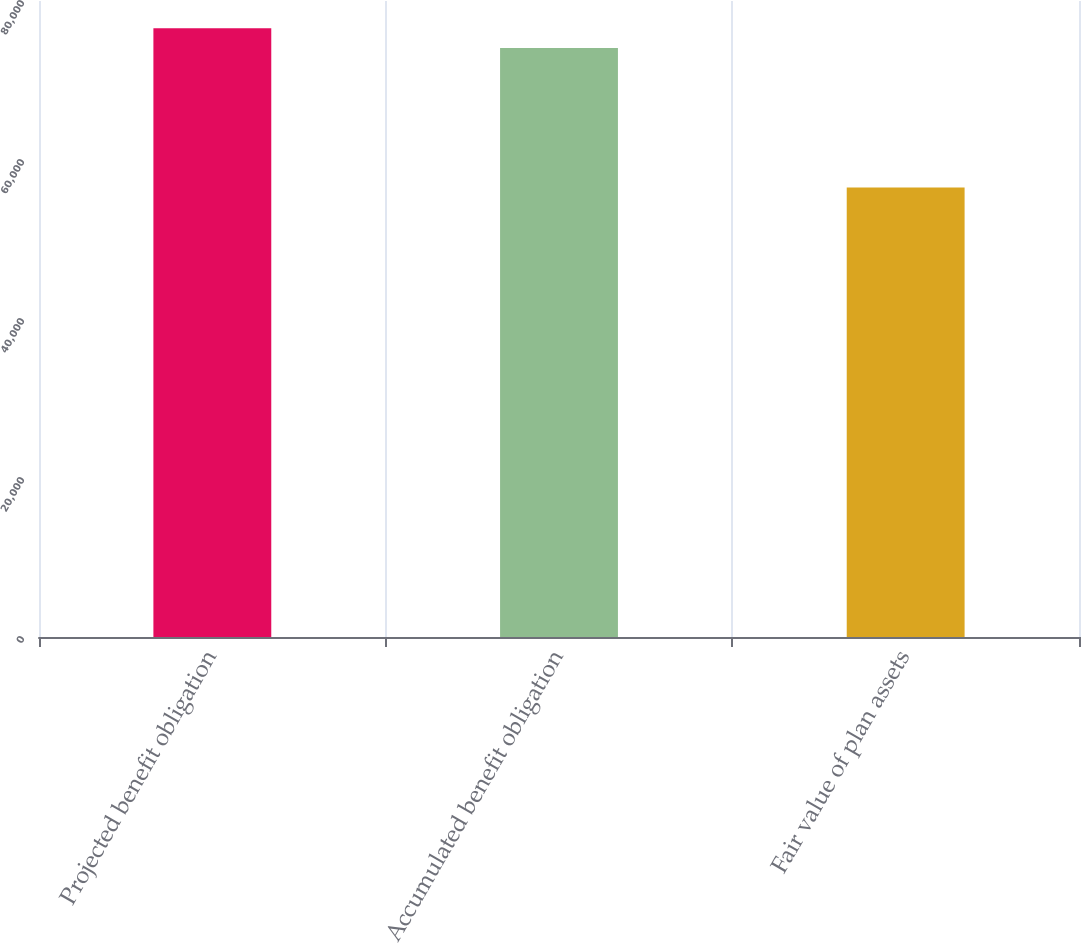<chart> <loc_0><loc_0><loc_500><loc_500><bar_chart><fcel>Projected benefit obligation<fcel>Accumulated benefit obligation<fcel>Fair value of plan assets<nl><fcel>76586<fcel>74081<fcel>56530<nl></chart> 